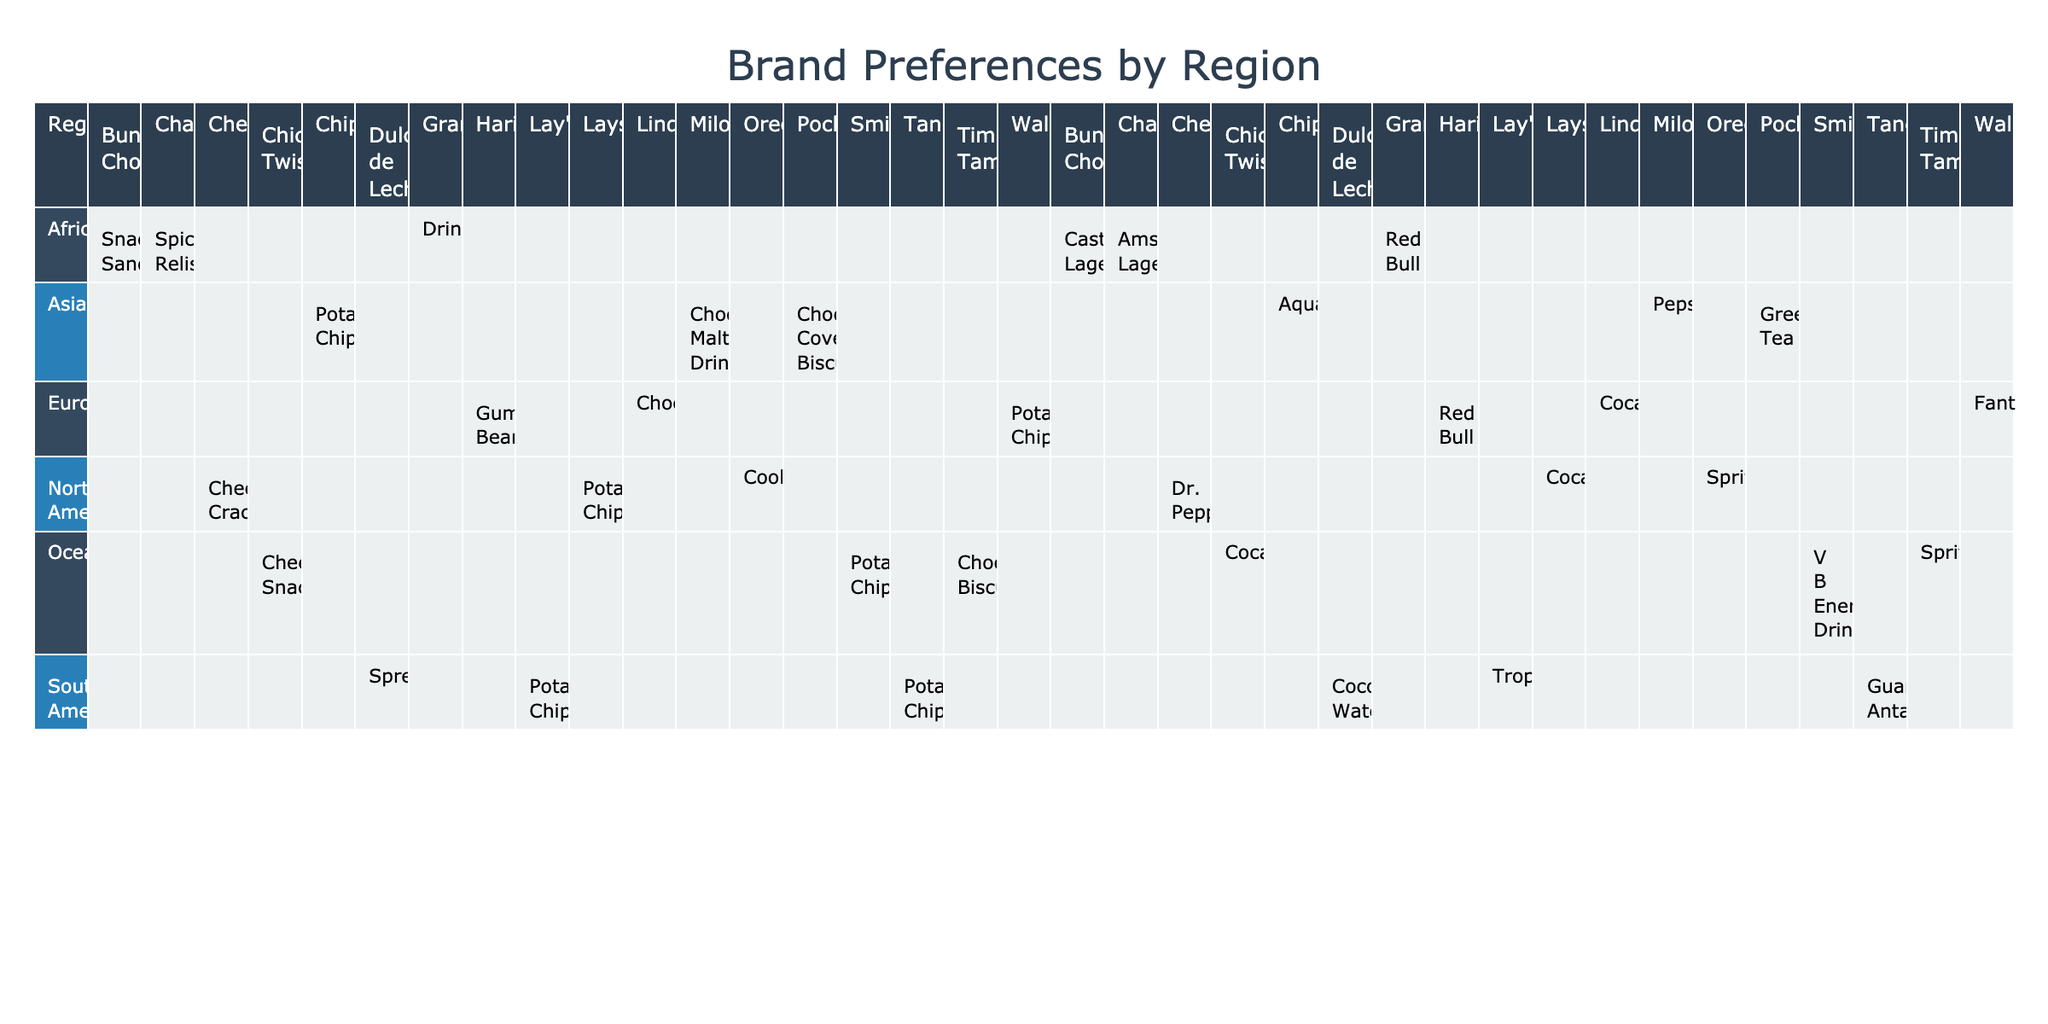What snack is preferred in South America? Looking at the South America row in the table, the snack preference listed is "Potato Chips" for both Tango and Lay's. However, Dulce de Leche is a spread and not a snack. The answer is based on the snack preference shown for brands in that region.
Answer: Potato Chips Which drink is most frequently preferred in North America? In the North America section, three brands are listed: Lays, Cheez-It, and Oreos. The drinks associated with these brands are Coca-Cola, Dr. Pepper, and Sprite respectively. There is no repetition of a drink among these brands, indicating multiple choices but no single predominant option.
Answer: No single drink is most frequent Is Haribo a preferred snack in Europe? Checking the Europe row, Haribo is listed with a snack preference of "Gummy Bears." Therefore, it is confirmed as a preferred snack in that region.
Answer: Yes What is the total number of unique snacks listed across all regions? First, we will identify all the unique snacks mentioned in the table: Potato Chips, Cheese Crackers, Cookies, Chocolate, Gummy Bears, Chocolate Covered Biscuit, Chocolate Malt Drink, Spread, Drink (Granadilla), and Cheese Snack. Counting these, we find there are 10 unique snacks.
Answer: 10 Which region has the highest variety of drink preferences? To determine the region with the most drink preferences, we will analyze each region's brands and their associated drinks. North America has 3 drinks, Europe has 3, Asia has 3, South America has 3, Africa has 3, and Oceania has 3. Every region has the same number of drink preferences, so no region has a higher variety.
Answer: All regions have equal variety What snack do both North America and Oceania share? In the North America category, the snack options are Lays (Potato Chips), Cheez-It (Cheese Crackers), and Oreos (Cookies). In Oceania, the snacks are Smith's (Potato Chips), Tim Tams (Chocolate Biscuits), and Chicken Twisties (Cheese Snack). The only snack common to both regions is "Potato Chips."
Answer: Potato Chips Is there any region where the preferred drink is Red Bull? Looking through the regions listed, Red Bull is seen in Europe (with Haribo) and Africa (with Granadilla). The presence of Red Bull in multiple regions confirms that there is no exclusive region for it.
Answer: Yes, Europe and Africa both prefer Red Bull How many snacks listed are chocolate-related? We identify chocolate-related snacks from the table: Oreos (Cookies), Lindt (Chocolate), Pocky (Chocolate Covered Biscuit), Milo (Chocolate Malt Drink), and Tim Tams (Chocolate Biscuits). Counting these gives us five chocolate-related snacks across all regions.
Answer: 5 In which region is the only snack spread listed? The row for South America shows "Dulce de Leche" which is categorized as a spread. This makes South America the region with the only snack classified as a spread when comparing all regions.
Answer: South America Which brand is associated with the drink Coca-Cola in Oceania? In the Oceania section, Coca-Cola is associated with Chicken Twisties as their drink preference. Thus, it confirms that Coca-Cola is linked to that brand in this region specifically.
Answer: Chicken Twisties 